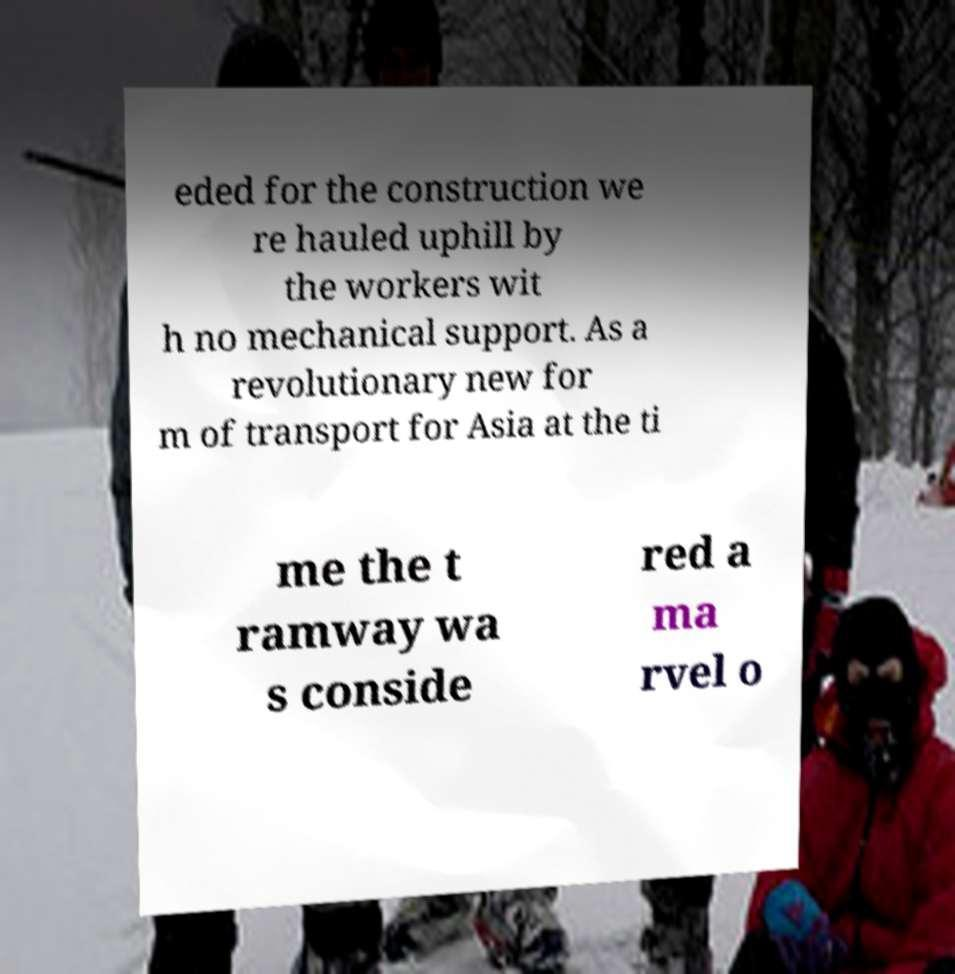Can you accurately transcribe the text from the provided image for me? eded for the construction we re hauled uphill by the workers wit h no mechanical support. As a revolutionary new for m of transport for Asia at the ti me the t ramway wa s conside red a ma rvel o 